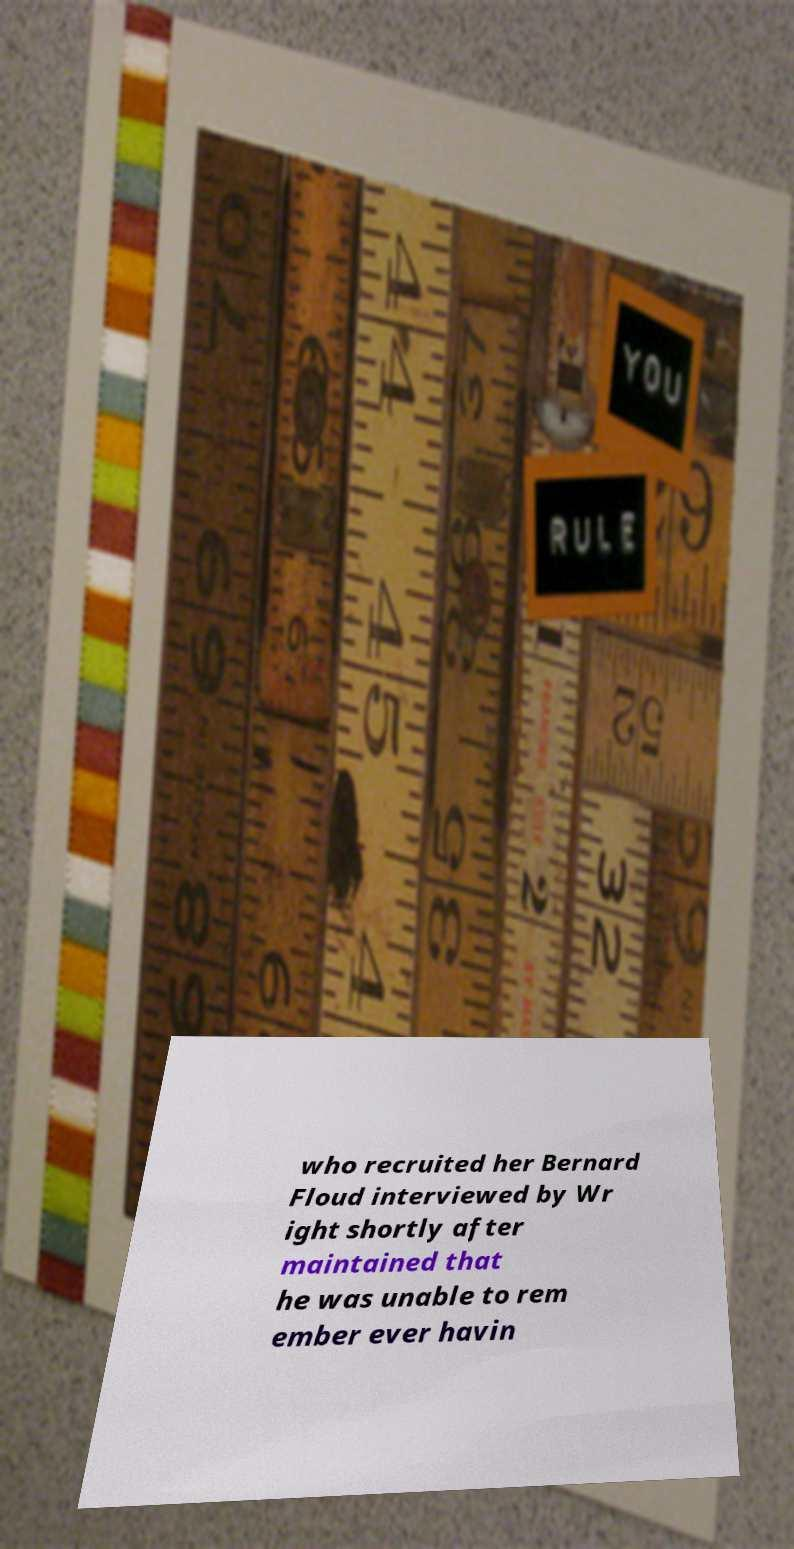Could you assist in decoding the text presented in this image and type it out clearly? who recruited her Bernard Floud interviewed by Wr ight shortly after maintained that he was unable to rem ember ever havin 